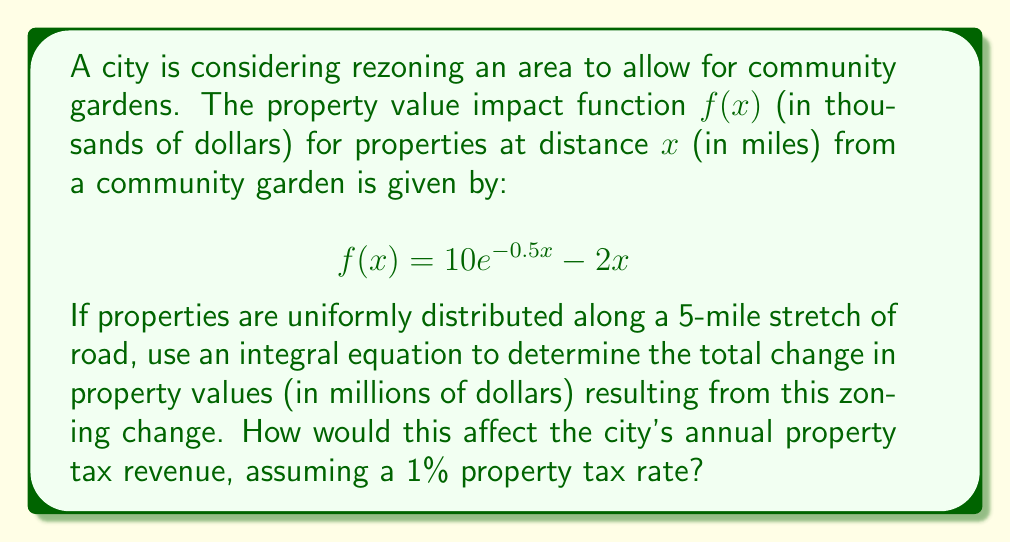Could you help me with this problem? 1) First, we need to set up the integral to calculate the total change in property values:

   $$\text{Total Change} = \int_0^5 f(x) dx = \int_0^5 (10e^{-0.5x} - 2x) dx$$

2) Let's solve this integral:
   
   $$\int_0^5 (10e^{-0.5x} - 2x) dx = \left[-20e^{-0.5x} - x^2\right]_0^5$$

3) Evaluate the integral:
   
   $$= (-20e^{-2.5} - 25) - (-20 - 0) = -20e^{-2.5} - 25 + 20$$
   
   $$= -20e^{-2.5} - 5 \approx -6.69$$

4) The result is in thousands of dollars, so we need to convert to millions:
   
   $$-6.69 \text{ thousand} = -0.00669 \text{ million}$$

5) To calculate the impact on annual property tax revenue:
   
   $$\text{Tax Revenue Change} = -0.00669 \times 0.01 = -0.0000669 \text{ million}$$
   
   $$= -66.9 \text{ dollars}$$
Answer: $-0.00669 million in property value change; $66.9 annual tax revenue loss 